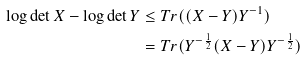Convert formula to latex. <formula><loc_0><loc_0><loc_500><loc_500>\log \det X - \log \det Y & \leq T r ( ( X - Y ) Y ^ { - 1 } ) \\ & = T r ( Y ^ { - \frac { 1 } { 2 } } ( X - Y ) Y ^ { - \frac { 1 } { 2 } } )</formula> 